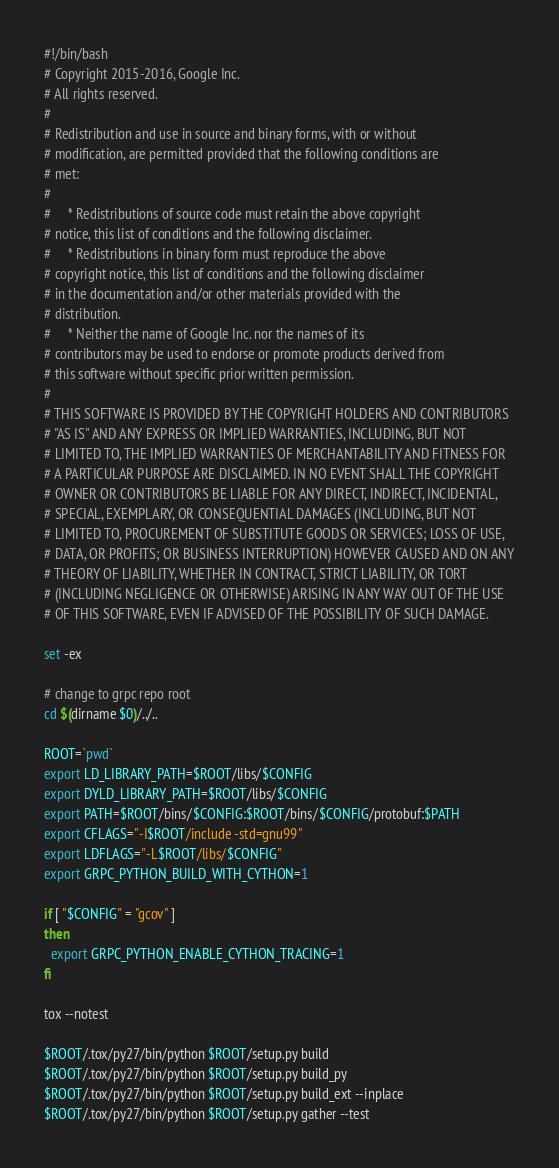Convert code to text. <code><loc_0><loc_0><loc_500><loc_500><_Bash_>#!/bin/bash
# Copyright 2015-2016, Google Inc.
# All rights reserved.
#
# Redistribution and use in source and binary forms, with or without
# modification, are permitted provided that the following conditions are
# met:
#
#     * Redistributions of source code must retain the above copyright
# notice, this list of conditions and the following disclaimer.
#     * Redistributions in binary form must reproduce the above
# copyright notice, this list of conditions and the following disclaimer
# in the documentation and/or other materials provided with the
# distribution.
#     * Neither the name of Google Inc. nor the names of its
# contributors may be used to endorse or promote products derived from
# this software without specific prior written permission.
#
# THIS SOFTWARE IS PROVIDED BY THE COPYRIGHT HOLDERS AND CONTRIBUTORS
# "AS IS" AND ANY EXPRESS OR IMPLIED WARRANTIES, INCLUDING, BUT NOT
# LIMITED TO, THE IMPLIED WARRANTIES OF MERCHANTABILITY AND FITNESS FOR
# A PARTICULAR PURPOSE ARE DISCLAIMED. IN NO EVENT SHALL THE COPYRIGHT
# OWNER OR CONTRIBUTORS BE LIABLE FOR ANY DIRECT, INDIRECT, INCIDENTAL,
# SPECIAL, EXEMPLARY, OR CONSEQUENTIAL DAMAGES (INCLUDING, BUT NOT
# LIMITED TO, PROCUREMENT OF SUBSTITUTE GOODS OR SERVICES; LOSS OF USE,
# DATA, OR PROFITS; OR BUSINESS INTERRUPTION) HOWEVER CAUSED AND ON ANY
# THEORY OF LIABILITY, WHETHER IN CONTRACT, STRICT LIABILITY, OR TORT
# (INCLUDING NEGLIGENCE OR OTHERWISE) ARISING IN ANY WAY OUT OF THE USE
# OF THIS SOFTWARE, EVEN IF ADVISED OF THE POSSIBILITY OF SUCH DAMAGE.

set -ex

# change to grpc repo root
cd $(dirname $0)/../..

ROOT=`pwd`
export LD_LIBRARY_PATH=$ROOT/libs/$CONFIG
export DYLD_LIBRARY_PATH=$ROOT/libs/$CONFIG
export PATH=$ROOT/bins/$CONFIG:$ROOT/bins/$CONFIG/protobuf:$PATH
export CFLAGS="-I$ROOT/include -std=gnu99"
export LDFLAGS="-L$ROOT/libs/$CONFIG"
export GRPC_PYTHON_BUILD_WITH_CYTHON=1

if [ "$CONFIG" = "gcov" ]
then
  export GRPC_PYTHON_ENABLE_CYTHON_TRACING=1
fi

tox --notest

$ROOT/.tox/py27/bin/python $ROOT/setup.py build
$ROOT/.tox/py27/bin/python $ROOT/setup.py build_py
$ROOT/.tox/py27/bin/python $ROOT/setup.py build_ext --inplace
$ROOT/.tox/py27/bin/python $ROOT/setup.py gather --test
</code> 